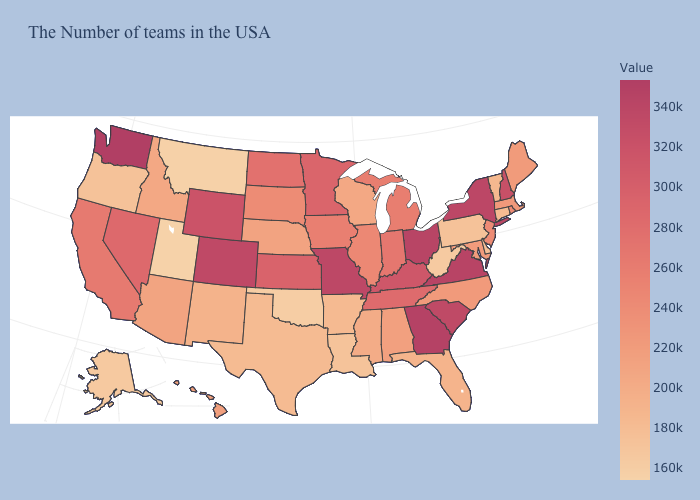Does Idaho have a higher value than Connecticut?
Short answer required. Yes. Which states have the highest value in the USA?
Be succinct. Washington. Which states have the highest value in the USA?
Answer briefly. Washington. Among the states that border Pennsylvania , does New Jersey have the lowest value?
Give a very brief answer. No. 